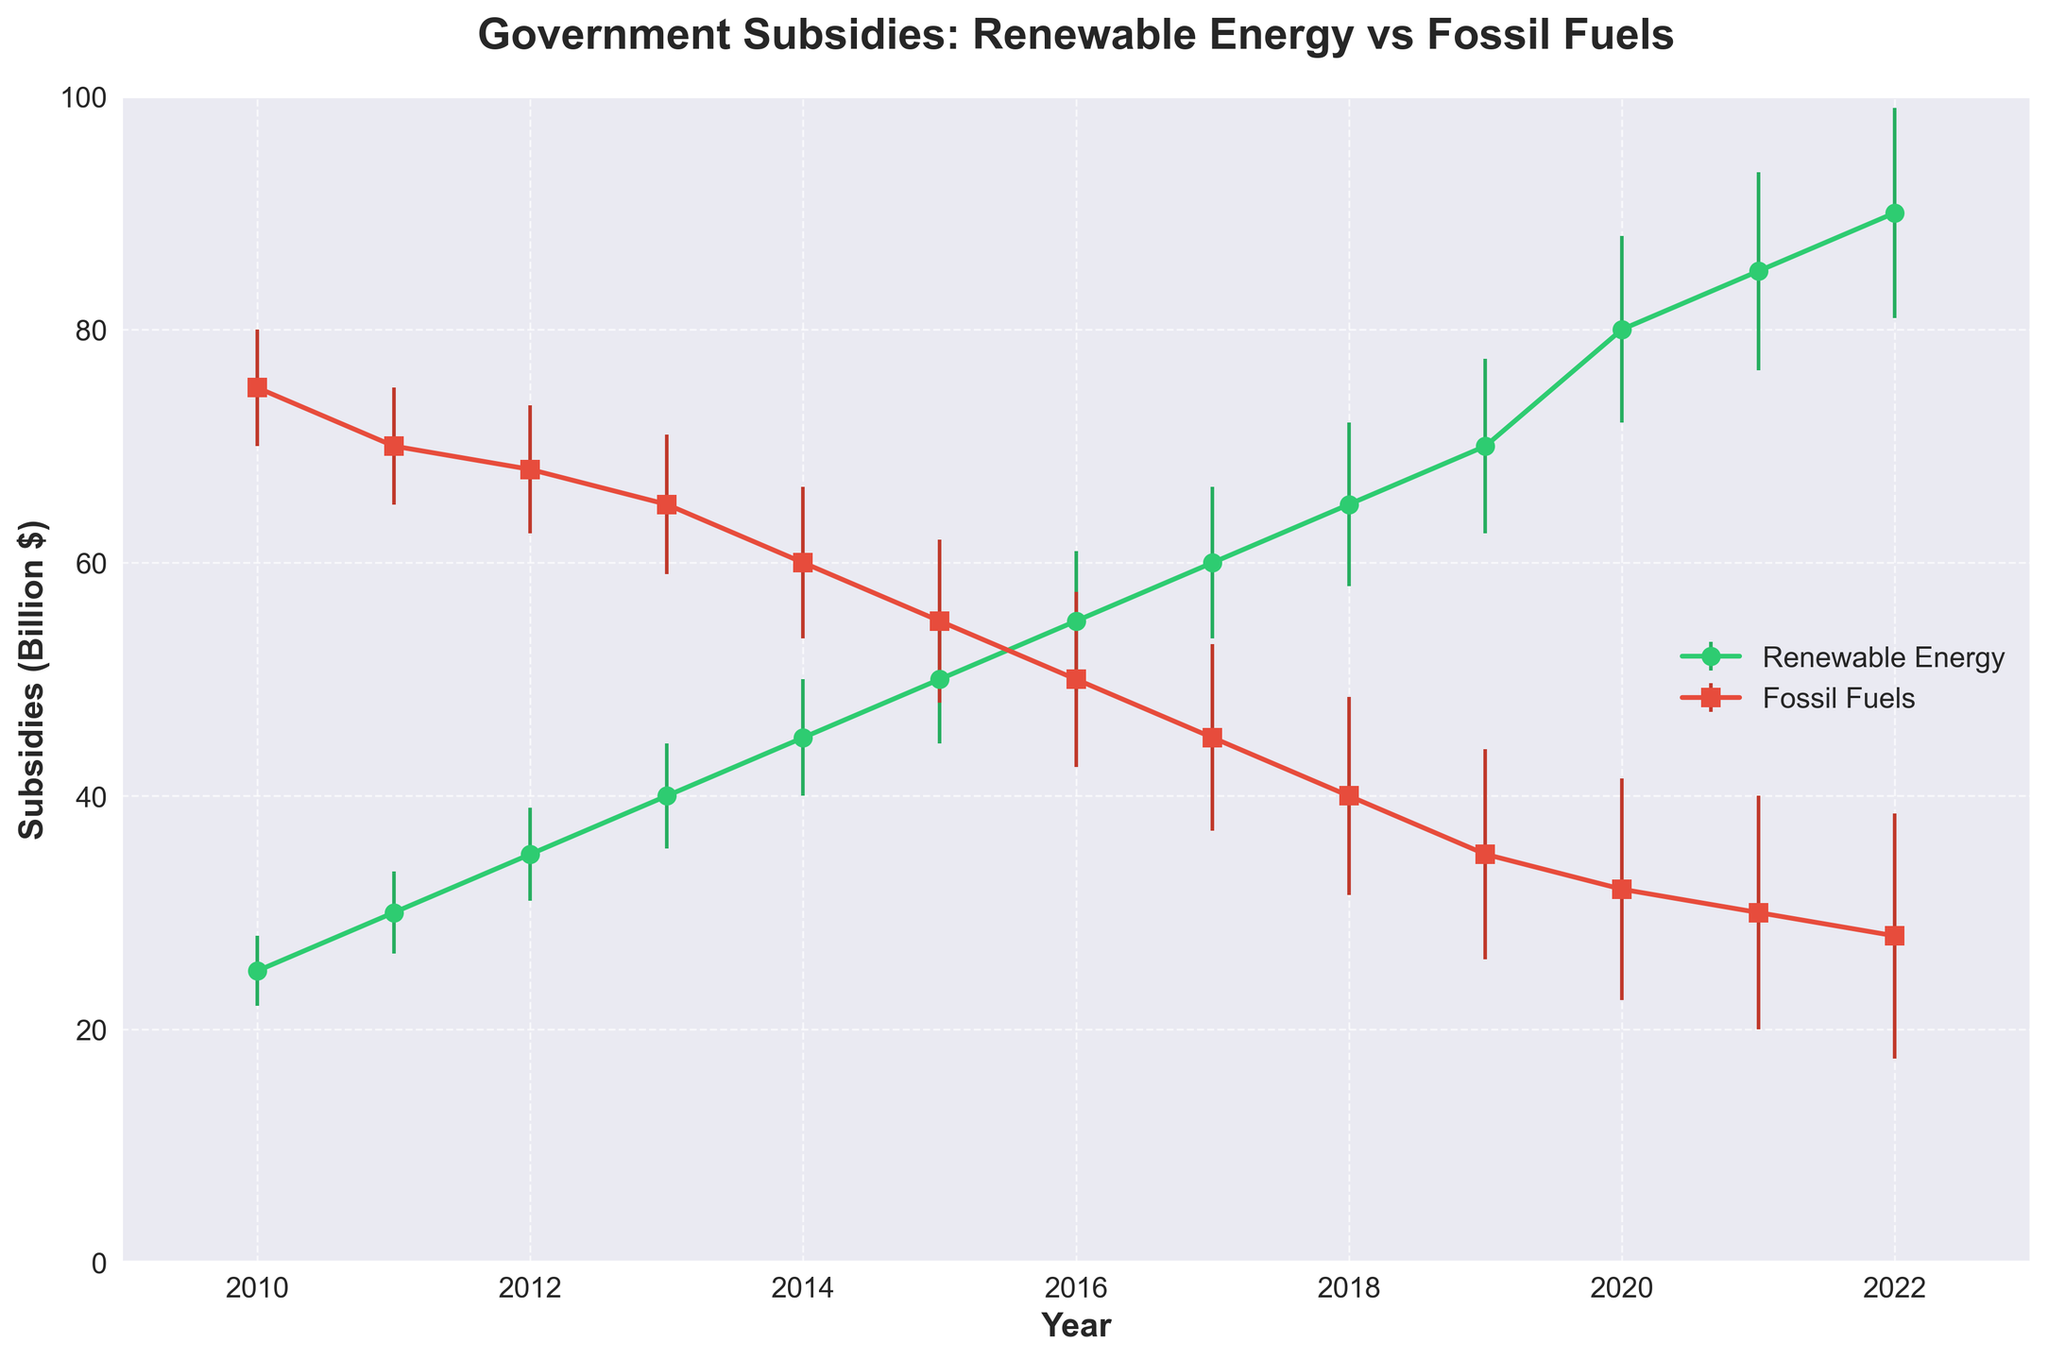What is the main title of the figure? The title of the figure is the largest text element positioned at the top. It reads "Government Subsidies: Renewable Energy vs Fossil Fuels."
Answer: "Government Subsidies: Renewable Energy vs Fossil Fuels" Which energy type had the higher subsidy in 2010? By referring to the line plot for the year 2010, the point representing Fossil Fuels subsidies is higher than the one for Renewable Energy.
Answer: Fossil Fuels What is the highest subsidy value for renewable energy in the plotted period? The highest subsidy value occurs at the highest point on the Renewable Energy line. This peak is reached in 2022 at 90 billion dollars.
Answer: 90 billion dollars How did the subsidies for fossil fuels change from 2010 to 2022? To determine the change, examine the overall trend from the starting point in 2010 to the ending point in 2022 on the Fossil Fuels line. It shows a consistent decline from 75 billion dollars to 28 billion dollars.
Answer: Decreased In what year do Renewable Energy and Fossil Fuels subsidies appear to be closest in value? Locate the points on both lines where the values of the subsidies appear closest to each other. In 2021, the subsidies are closest, with Renewable Energy at 85 billion dollars and Fossil Fuels at 30 billion dollars.
Answer: 2021 How large is the subsidy difference between Renewable Energy and Fossil Fuels in 2020? Find the subsidy values for both energy types in 2020: Renewable Energy is at 80 billion dollars, and Fossil Fuels are at 32 billion dollars. The difference is 80 - 32.
Answer: 48 billion dollars Which year had the highest standard deviation for Fossil Fuels subsidies? Examine the error bars for Fossil Fuels subsidies. The highest error bar corresponds to the year 2022 with a standard deviation of 10.5.
Answer: 2022 What notable trend can be observed in Renewable Energy subsidies from 2010 to 2022? The Renewable Energy subsidies show a clear upward trend from 25 billion dollars in 2010 to 90 billion dollars in 2022, indicating consistent growth over the years.
Answer: Consistent growth Compare the trend lines for Renewable Energy and Fossil Fuels subsidies. What does this reveal about government policy changes over the years? By comparing the trends, Renewable Energy subsidies increase steadily while Fossil Fuels subsidies decrease over the same period, revealing a policy shift towards supporting renewable energy.
Answer: Shift towards Renewable Energy 